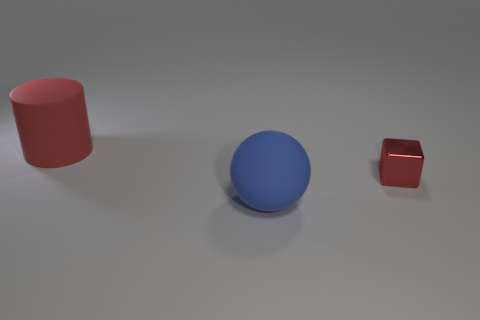Add 1 cyan shiny objects. How many objects exist? 4 Subtract all cylinders. How many objects are left? 2 Add 2 metallic things. How many metallic things are left? 3 Add 3 small metal blocks. How many small metal blocks exist? 4 Subtract 0 brown spheres. How many objects are left? 3 Subtract all gray matte objects. Subtract all red shiny blocks. How many objects are left? 2 